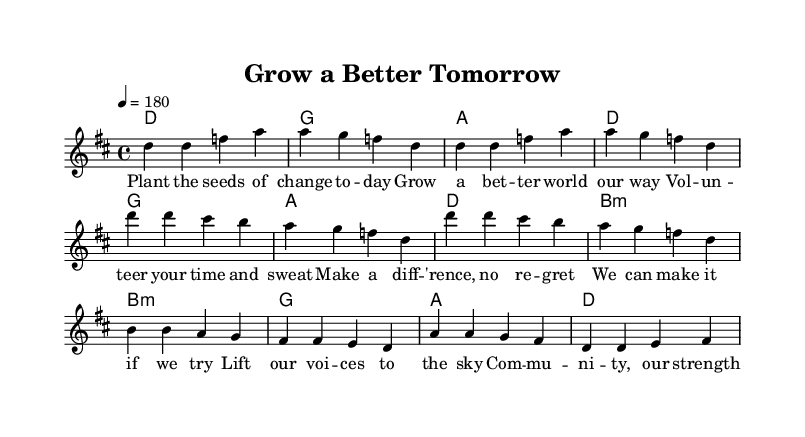What is the key signature of this music? The key signature is D major, which has two sharps: F# and C#.
Answer: D major What is the time signature of this music? The time signature is 4/4, indicating there are four beats in each measure.
Answer: 4/4 What is the tempo marked for this piece? The tempo marking is 180, indicating the speed of the music is 180 beats per minute.
Answer: 180 How many measures are there in the verse? The verse consists of 4 measures as indicated by the sections denoted in the music.
Answer: 4 What primary theme does this music focus on? The primary theme of the song addresses community volunteering and activism.
Answer: Community volunteering and activism What chords are used in the chorus? The chords in the chorus are G, A, D, and B minor, as indicated in the harmonic notation.
Answer: G, A, D, B minor Which section contains a call to action? The lyrics of the chorus include a call to action with phrases that encourage collective effort and activism.
Answer: Chorus 